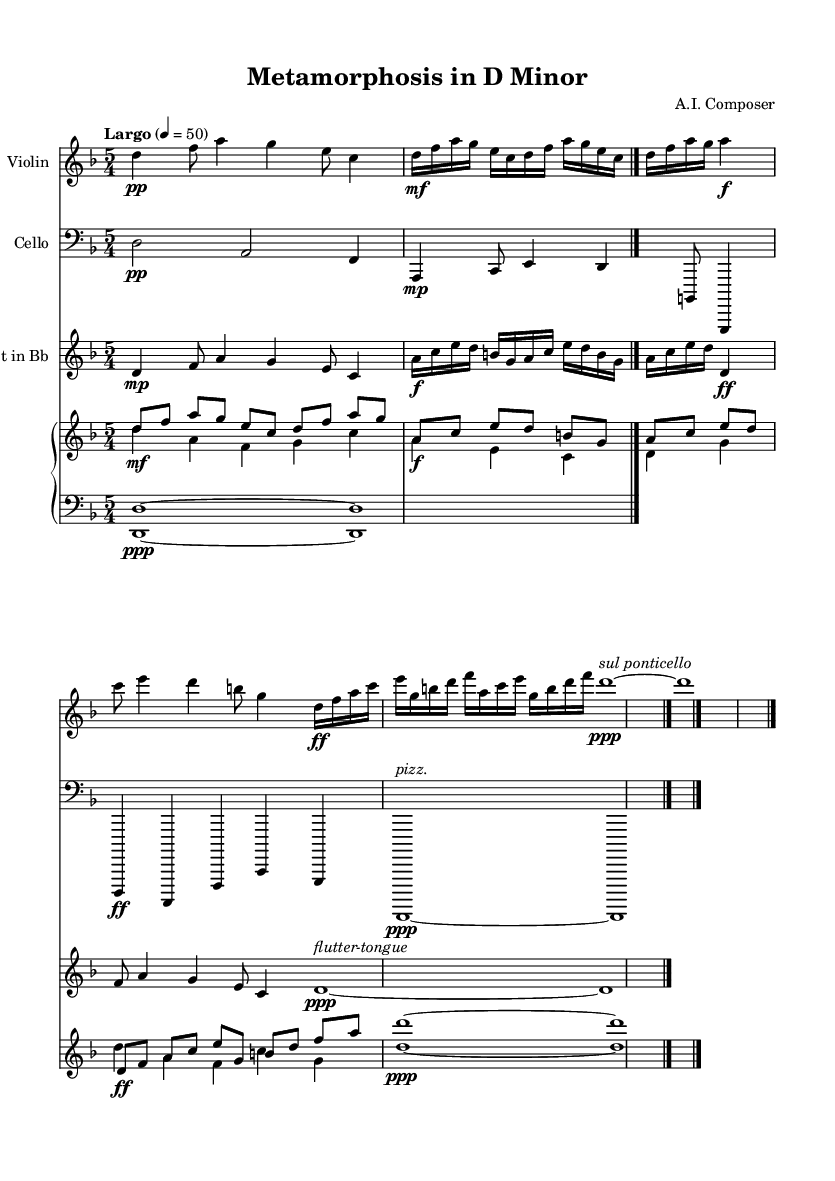What is the key signature of this music? The key signature is D minor, which has one flat (B flat).
Answer: D minor What is the time signature of this piece? The time signature of the piece is 5/4, indicating five beats per measure.
Answer: 5/4 What is the tempo marking for this composition? The tempo marking is "Largo," which suggests a slow and broad pace.
Answer: Largo How many staff sections are present in the score? There are four staff sections visible in the score: one each for violin, cello, clarinet, and a piano with two staves (treble and bass).
Answer: Four What instrumental technique is suggested in the coda for the violin? The technique suggested in the coda for the violin is "sul ponticello," indicating that the player should bow near the bridge of the instrument.
Answer: sul ponticello In the transformation section, how many notes are present for the clarinet? The clarinet plays a total of 16 notes in the transformation section as indicated by the sixteenth note groupings.
Answer: 16 Which instrument participates in the "Fusion" section? The instruments participating in the "Fusion" section are the violin, cello, clarinet, and both parts of the piano.
Answer: Violin, cello, clarinet, piano 